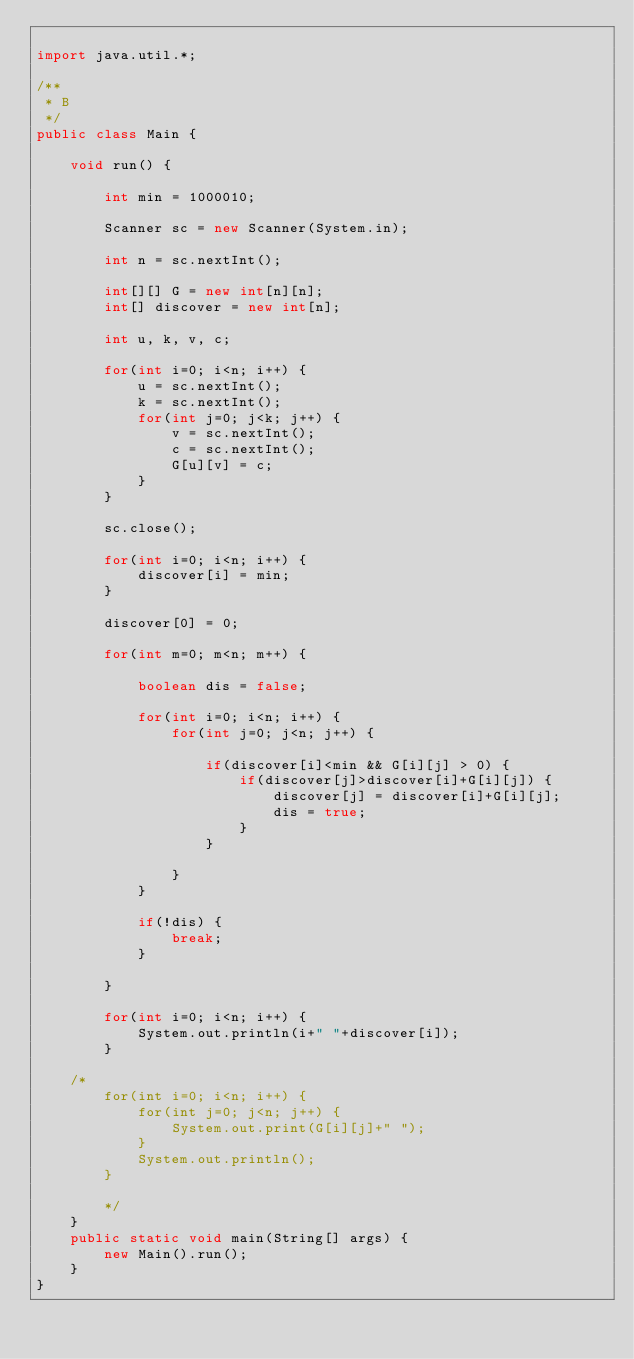Convert code to text. <code><loc_0><loc_0><loc_500><loc_500><_Java_>
import java.util.*;

/**
 * B
 */
public class Main {
    
    void run() {

        int min = 1000010;
        
        Scanner sc = new Scanner(System.in);
        
        int n = sc.nextInt();

        int[][] G = new int[n][n];
        int[] discover = new int[n];

        int u, k, v, c;

        for(int i=0; i<n; i++) {
            u = sc.nextInt();
            k = sc.nextInt();
            for(int j=0; j<k; j++) {
                v = sc.nextInt();
                c = sc.nextInt();
                G[u][v] = c;
            }
        }

        sc.close();

        for(int i=0; i<n; i++) {
            discover[i] = min;
        }

        discover[0] = 0;

        for(int m=0; m<n; m++) {

            boolean dis = false;

            for(int i=0; i<n; i++) {
                for(int j=0; j<n; j++) {

                    if(discover[i]<min && G[i][j] > 0) {
                        if(discover[j]>discover[i]+G[i][j]) {
                            discover[j] = discover[i]+G[i][j];
                            dis = true;
                        }
                    }

                }
            }

            if(!dis) {
                break;
            }

        }

        for(int i=0; i<n; i++) {
            System.out.println(i+" "+discover[i]);
        }

    /*
        for(int i=0; i<n; i++) {
            for(int j=0; j<n; j++) {
                System.out.print(G[i][j]+" ");
            }
            System.out.println();
        }
        
        */
    }
    public static void main(String[] args) {
        new Main().run();
    }
}
</code> 